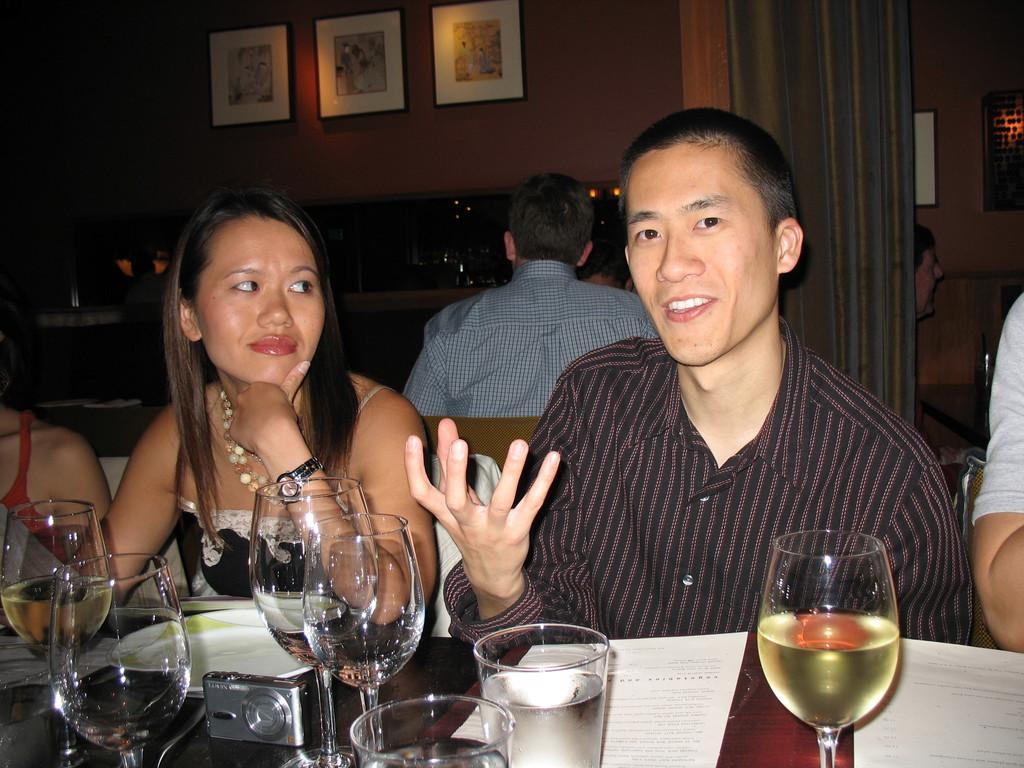Could you give a brief overview of what you see in this image? In this image I can see at the bottom there are wine glasses on the table. On the right side a man is talking, he is wearing a shirt, beside him there is a woman looking at him. At the top it looks like there are photo frames on the wall. 